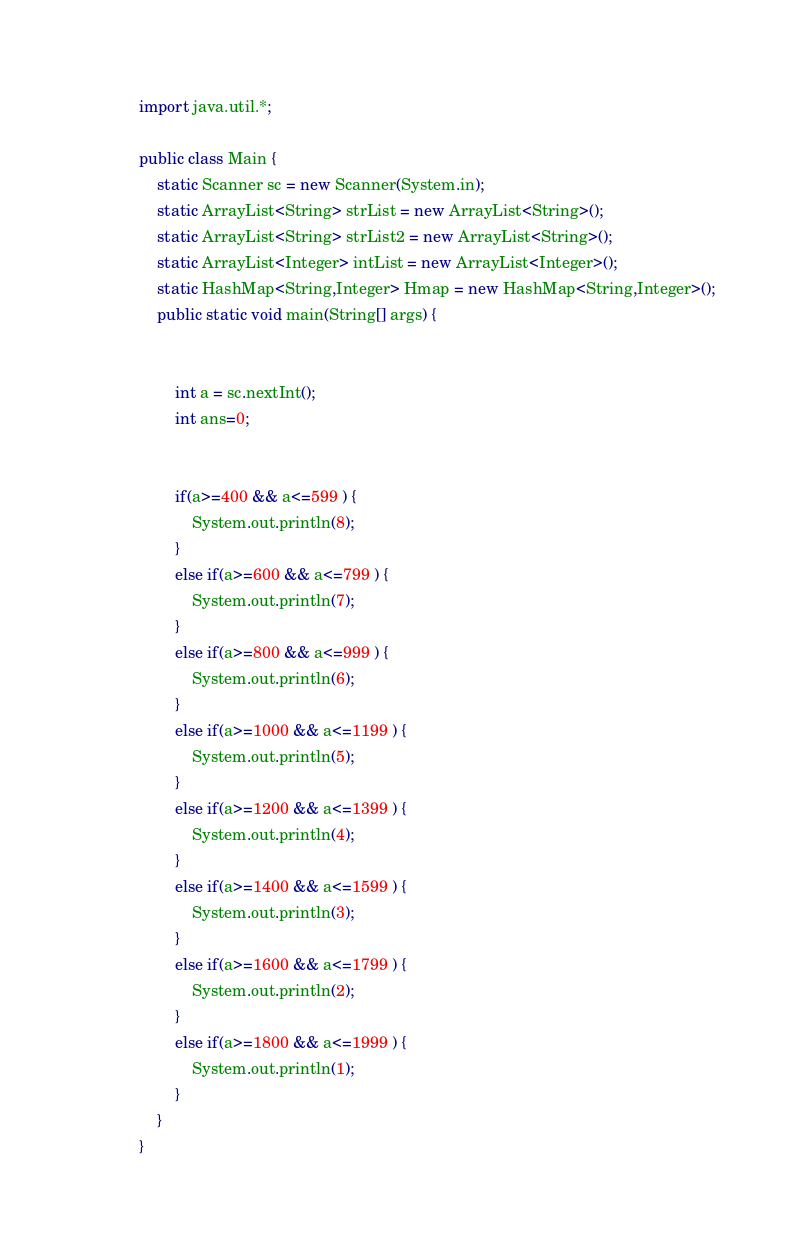Convert code to text. <code><loc_0><loc_0><loc_500><loc_500><_Java_>import java.util.*;

public class Main {
	static Scanner sc = new Scanner(System.in);
	static ArrayList<String> strList = new ArrayList<String>();
	static ArrayList<String> strList2 = new ArrayList<String>();
	static ArrayList<Integer> intList = new ArrayList<Integer>();
	static HashMap<String,Integer> Hmap = new HashMap<String,Integer>();
	public static void main(String[] args) {


		int a = sc.nextInt();
		int ans=0;
		
		
		if(a>=400 && a<=599 ) {
			System.out.println(8);
		}
		else if(a>=600 && a<=799 ) {
			System.out.println(7);
		}
		else if(a>=800 && a<=999 ) {
			System.out.println(6);
		}
		else if(a>=1000 && a<=1199 ) {
			System.out.println(5);
		}
		else if(a>=1200 && a<=1399 ) {
			System.out.println(4);
		}
		else if(a>=1400 && a<=1599 ) {
			System.out.println(3);
		}
		else if(a>=1600 && a<=1799 ) {
			System.out.println(2);
		}
		else if(a>=1800 && a<=1999 ) {
			System.out.println(1);
		}
	}
}

</code> 